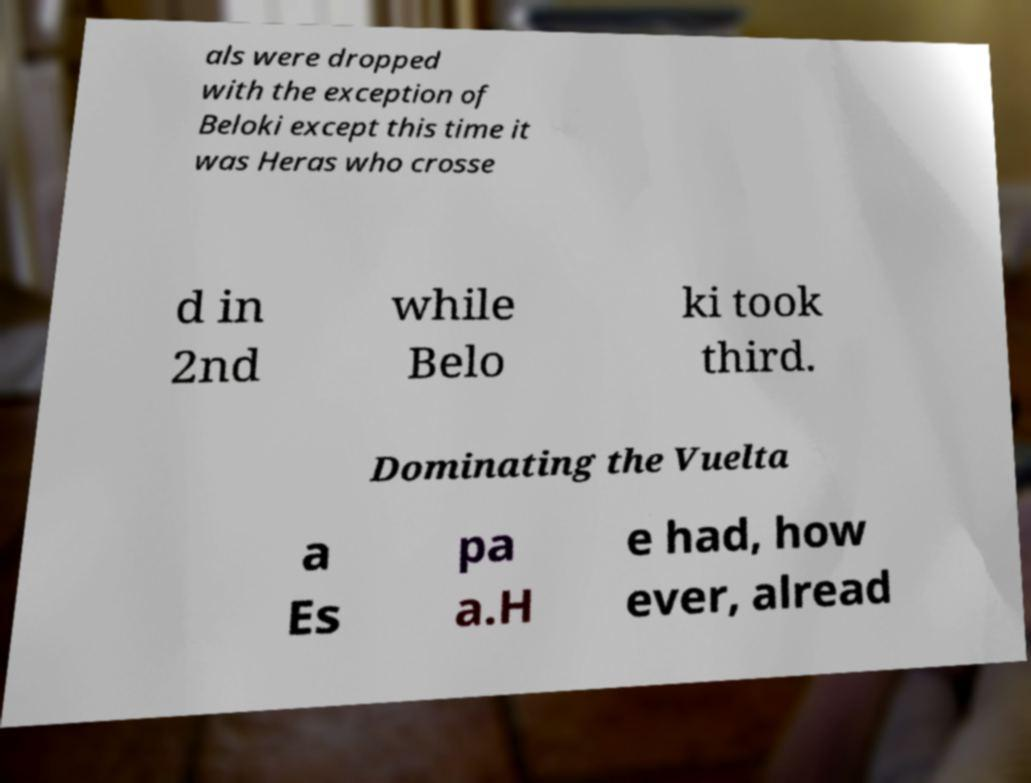Can you read and provide the text displayed in the image?This photo seems to have some interesting text. Can you extract and type it out for me? als were dropped with the exception of Beloki except this time it was Heras who crosse d in 2nd while Belo ki took third. Dominating the Vuelta a Es pa a.H e had, how ever, alread 